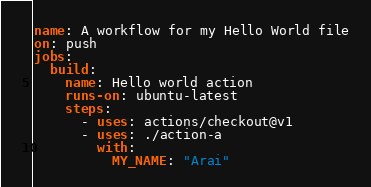Convert code to text. <code><loc_0><loc_0><loc_500><loc_500><_YAML_>name: A workflow for my Hello World file
on: push
jobs:
  build:
    name: Hello world action
    runs-on: ubuntu-latest
    steps:
      - uses: actions/checkout@v1
      - uses: ./action-a
        with:
          MY_NAME: "Arai"</code> 